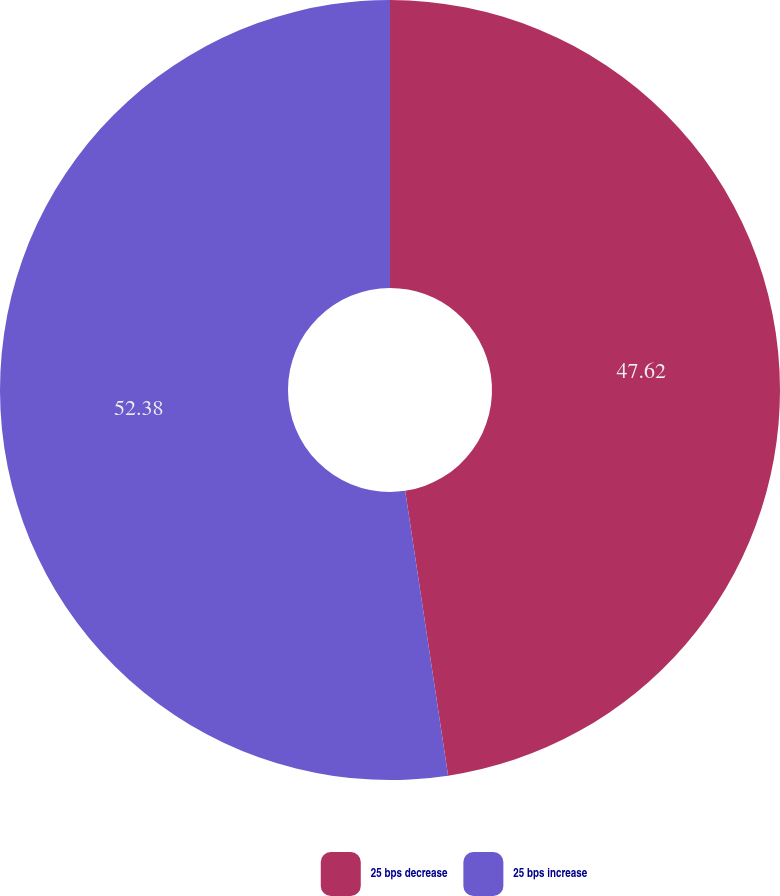Convert chart to OTSL. <chart><loc_0><loc_0><loc_500><loc_500><pie_chart><fcel>25 bps decrease<fcel>25 bps increase<nl><fcel>47.62%<fcel>52.38%<nl></chart> 